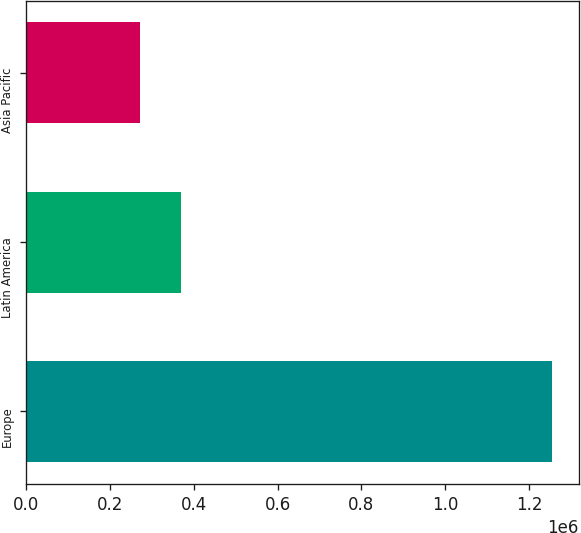<chart> <loc_0><loc_0><loc_500><loc_500><bar_chart><fcel>Europe<fcel>Latin America<fcel>Asia Pacific<nl><fcel>1.25443e+06<fcel>370771<fcel>272587<nl></chart> 